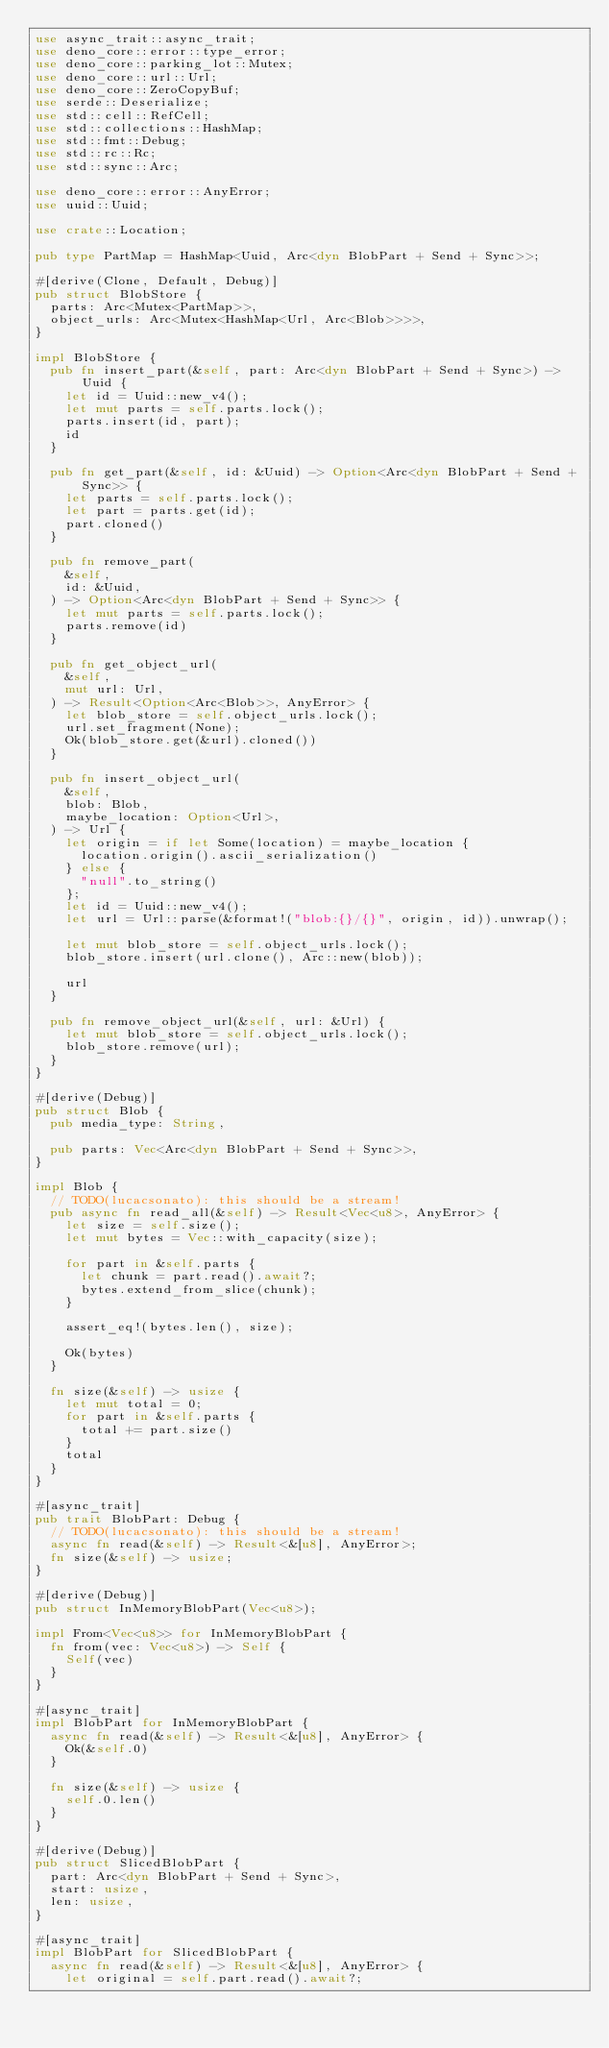<code> <loc_0><loc_0><loc_500><loc_500><_Rust_>use async_trait::async_trait;
use deno_core::error::type_error;
use deno_core::parking_lot::Mutex;
use deno_core::url::Url;
use deno_core::ZeroCopyBuf;
use serde::Deserialize;
use std::cell::RefCell;
use std::collections::HashMap;
use std::fmt::Debug;
use std::rc::Rc;
use std::sync::Arc;

use deno_core::error::AnyError;
use uuid::Uuid;

use crate::Location;

pub type PartMap = HashMap<Uuid, Arc<dyn BlobPart + Send + Sync>>;

#[derive(Clone, Default, Debug)]
pub struct BlobStore {
  parts: Arc<Mutex<PartMap>>,
  object_urls: Arc<Mutex<HashMap<Url, Arc<Blob>>>>,
}

impl BlobStore {
  pub fn insert_part(&self, part: Arc<dyn BlobPart + Send + Sync>) -> Uuid {
    let id = Uuid::new_v4();
    let mut parts = self.parts.lock();
    parts.insert(id, part);
    id
  }

  pub fn get_part(&self, id: &Uuid) -> Option<Arc<dyn BlobPart + Send + Sync>> {
    let parts = self.parts.lock();
    let part = parts.get(id);
    part.cloned()
  }

  pub fn remove_part(
    &self,
    id: &Uuid,
  ) -> Option<Arc<dyn BlobPart + Send + Sync>> {
    let mut parts = self.parts.lock();
    parts.remove(id)
  }

  pub fn get_object_url(
    &self,
    mut url: Url,
  ) -> Result<Option<Arc<Blob>>, AnyError> {
    let blob_store = self.object_urls.lock();
    url.set_fragment(None);
    Ok(blob_store.get(&url).cloned())
  }

  pub fn insert_object_url(
    &self,
    blob: Blob,
    maybe_location: Option<Url>,
  ) -> Url {
    let origin = if let Some(location) = maybe_location {
      location.origin().ascii_serialization()
    } else {
      "null".to_string()
    };
    let id = Uuid::new_v4();
    let url = Url::parse(&format!("blob:{}/{}", origin, id)).unwrap();

    let mut blob_store = self.object_urls.lock();
    blob_store.insert(url.clone(), Arc::new(blob));

    url
  }

  pub fn remove_object_url(&self, url: &Url) {
    let mut blob_store = self.object_urls.lock();
    blob_store.remove(url);
  }
}

#[derive(Debug)]
pub struct Blob {
  pub media_type: String,

  pub parts: Vec<Arc<dyn BlobPart + Send + Sync>>,
}

impl Blob {
  // TODO(lucacsonato): this should be a stream!
  pub async fn read_all(&self) -> Result<Vec<u8>, AnyError> {
    let size = self.size();
    let mut bytes = Vec::with_capacity(size);

    for part in &self.parts {
      let chunk = part.read().await?;
      bytes.extend_from_slice(chunk);
    }

    assert_eq!(bytes.len(), size);

    Ok(bytes)
  }

  fn size(&self) -> usize {
    let mut total = 0;
    for part in &self.parts {
      total += part.size()
    }
    total
  }
}

#[async_trait]
pub trait BlobPart: Debug {
  // TODO(lucacsonato): this should be a stream!
  async fn read(&self) -> Result<&[u8], AnyError>;
  fn size(&self) -> usize;
}

#[derive(Debug)]
pub struct InMemoryBlobPart(Vec<u8>);

impl From<Vec<u8>> for InMemoryBlobPart {
  fn from(vec: Vec<u8>) -> Self {
    Self(vec)
  }
}

#[async_trait]
impl BlobPart for InMemoryBlobPart {
  async fn read(&self) -> Result<&[u8], AnyError> {
    Ok(&self.0)
  }

  fn size(&self) -> usize {
    self.0.len()
  }
}

#[derive(Debug)]
pub struct SlicedBlobPart {
  part: Arc<dyn BlobPart + Send + Sync>,
  start: usize,
  len: usize,
}

#[async_trait]
impl BlobPart for SlicedBlobPart {
  async fn read(&self) -> Result<&[u8], AnyError> {
    let original = self.part.read().await?;</code> 